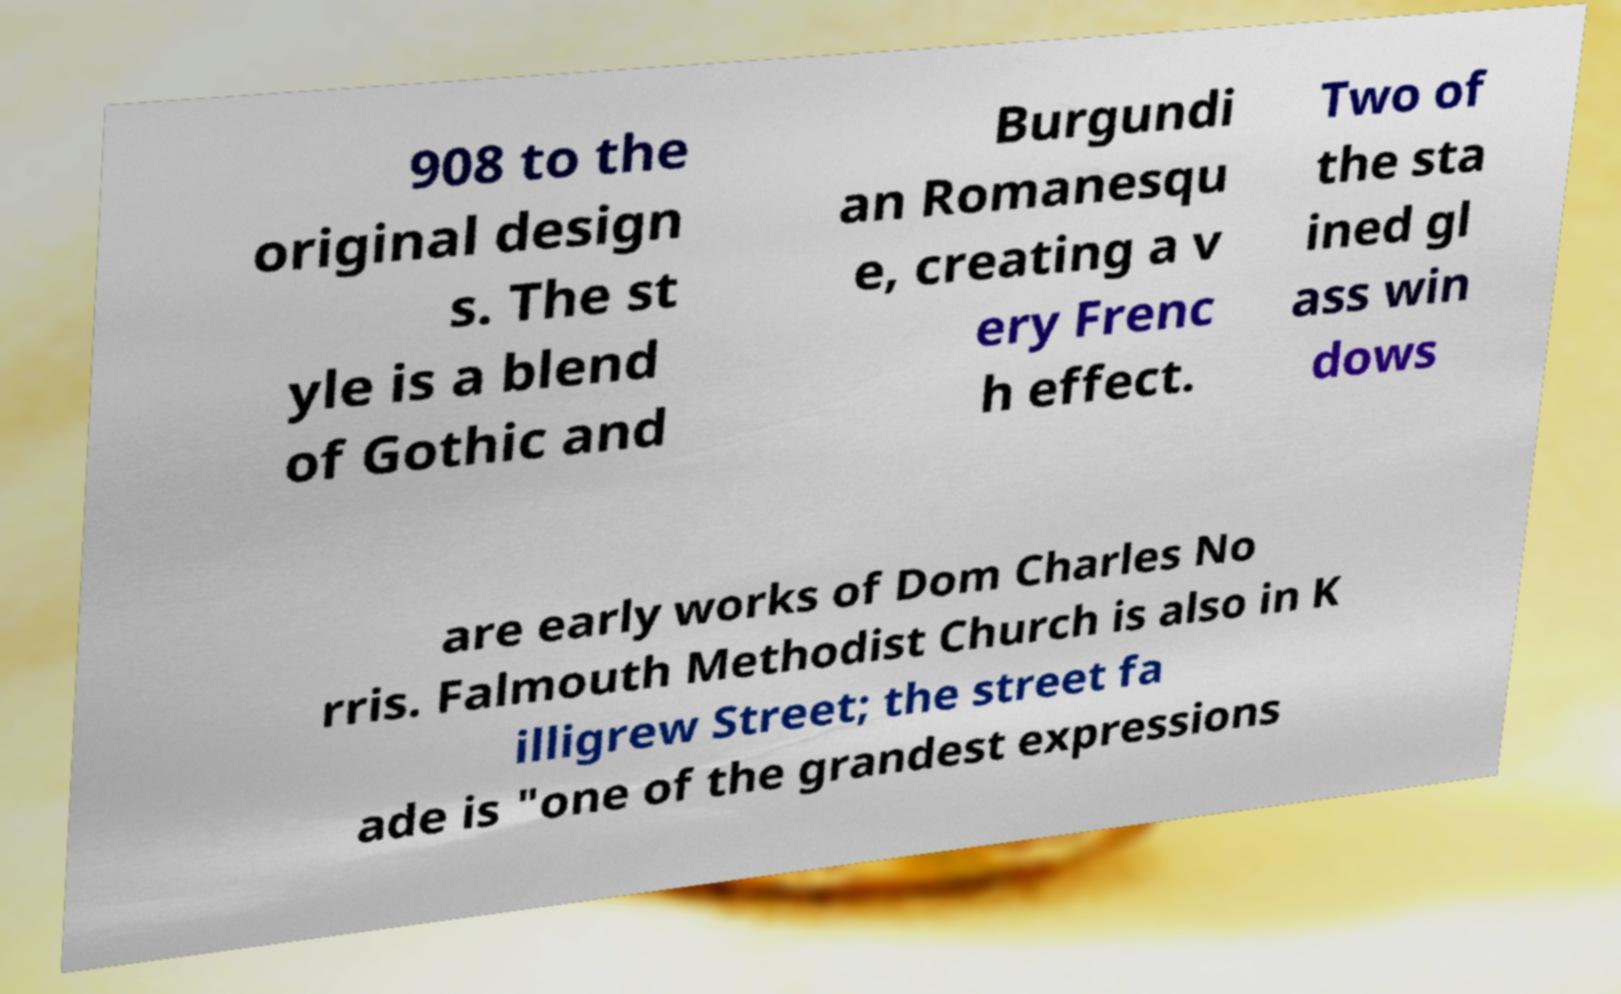Could you assist in decoding the text presented in this image and type it out clearly? 908 to the original design s. The st yle is a blend of Gothic and Burgundi an Romanesqu e, creating a v ery Frenc h effect. Two of the sta ined gl ass win dows are early works of Dom Charles No rris. Falmouth Methodist Church is also in K illigrew Street; the street fa ade is "one of the grandest expressions 